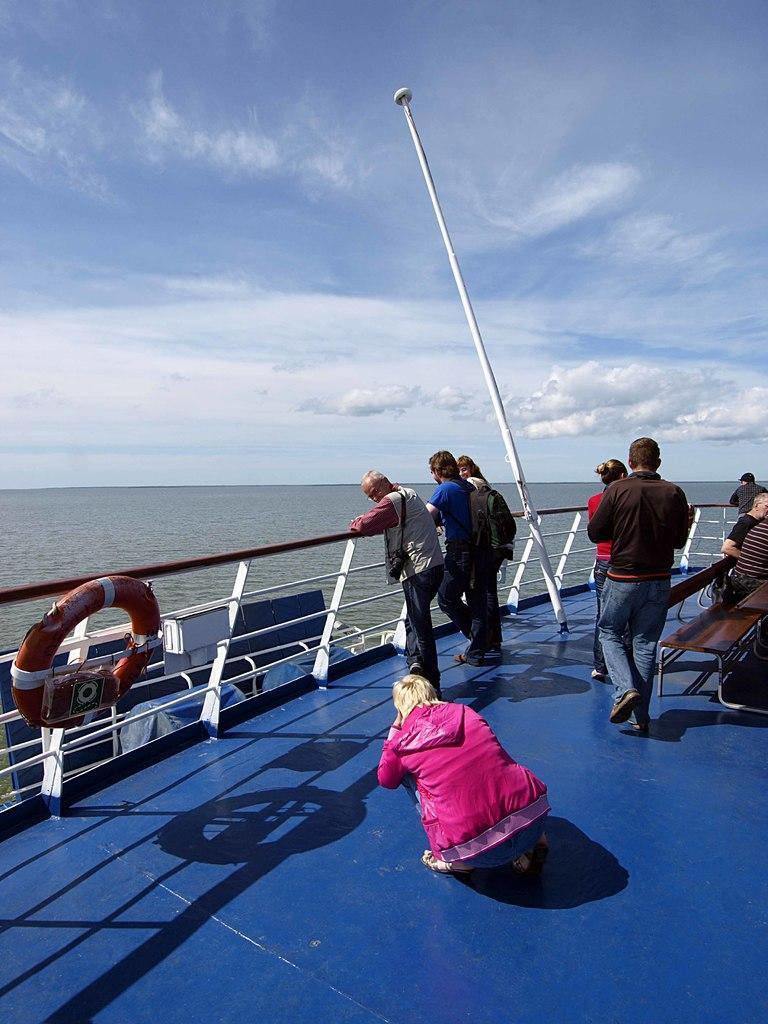Describe this image in one or two sentences. There is a ship. On the ship there are people. Also there is a railing with tube, pole and benches. In the background there is water and sky with clouds. 